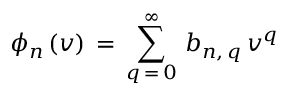Convert formula to latex. <formula><loc_0><loc_0><loc_500><loc_500>\phi _ { n } \, ( v ) \, = \, \sum _ { q \, = \, 0 } ^ { \infty } \, b _ { n , \, q } \, v ^ { q }</formula> 